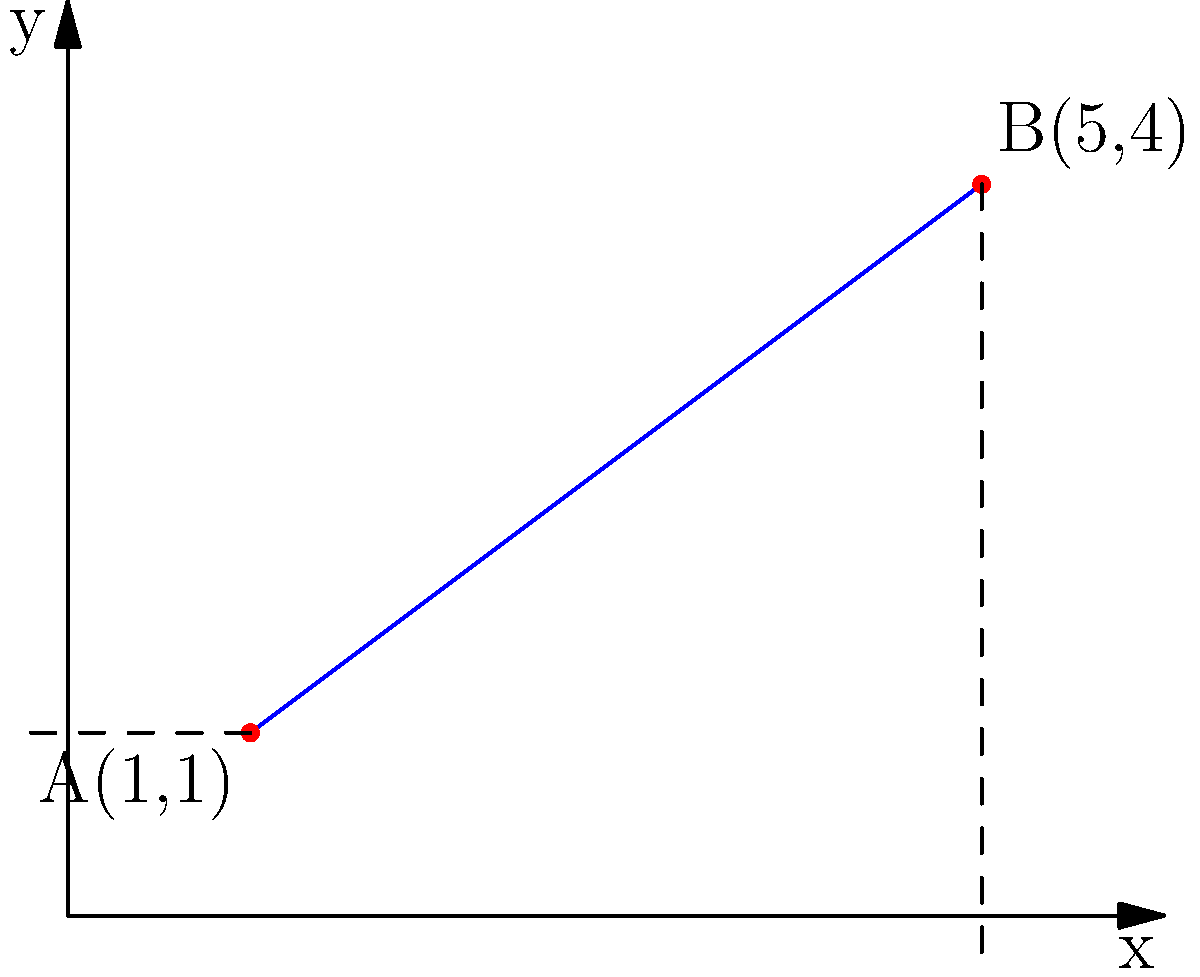In ballet, the angle of a dancer's leg in an arabesque position can be likened to the slope of a line. Consider two points on a coordinate plane representing the start and end positions of a dancer's leg: A(1,1) and B(5,4). Calculate the slope of the line connecting these two points, which represents the angle of the dancer's leg in the arabesque position. To find the slope of the line connecting two points, we use the slope formula:

$$ m = \frac{y_2 - y_1}{x_2 - x_1} $$

Where $(x_1, y_1)$ is the first point and $(x_2, y_2)$ is the second point.

Given:
Point A: $(x_1, y_1) = (1, 1)$
Point B: $(x_2, y_2) = (5, 4)$

Step 1: Substitute the values into the slope formula.
$$ m = \frac{4 - 1}{5 - 1} $$

Step 2: Simplify the numerator and denominator.
$$ m = \frac{3}{4} $$

Step 3: Express the result as a decimal (optional, depending on the required format).
$$ m = 0.75 $$

The slope of 0.75 (or 3/4) represents the rate at which the dancer's leg rises as it extends horizontally in the arabesque position. In ballet terms, this would correspond to a moderately high leg position, showcasing the dancer's flexibility and control.
Answer: $\frac{3}{4}$ or 0.75 